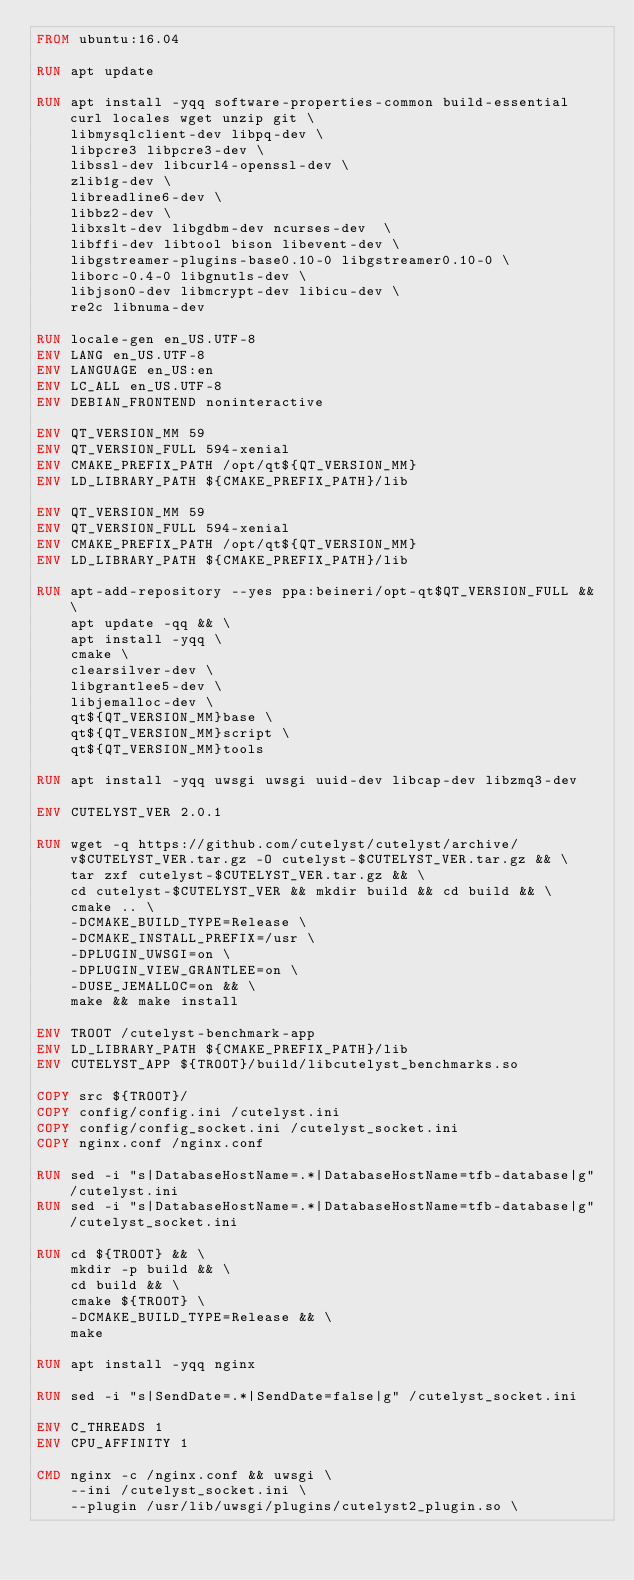<code> <loc_0><loc_0><loc_500><loc_500><_Dockerfile_>FROM ubuntu:16.04

RUN apt update

RUN apt install -yqq software-properties-common build-essential curl locales wget unzip git \
    libmysqlclient-dev libpq-dev \
    libpcre3 libpcre3-dev \
    libssl-dev libcurl4-openssl-dev \
    zlib1g-dev \
    libreadline6-dev \
    libbz2-dev \
    libxslt-dev libgdbm-dev ncurses-dev  \
    libffi-dev libtool bison libevent-dev \
    libgstreamer-plugins-base0.10-0 libgstreamer0.10-0 \
    liborc-0.4-0 libgnutls-dev \
    libjson0-dev libmcrypt-dev libicu-dev \
    re2c libnuma-dev

RUN locale-gen en_US.UTF-8
ENV LANG en_US.UTF-8
ENV LANGUAGE en_US:en
ENV LC_ALL en_US.UTF-8
ENV DEBIAN_FRONTEND noninteractive

ENV QT_VERSION_MM 59
ENV QT_VERSION_FULL 594-xenial
ENV CMAKE_PREFIX_PATH /opt/qt${QT_VERSION_MM}
ENV LD_LIBRARY_PATH ${CMAKE_PREFIX_PATH}/lib

ENV QT_VERSION_MM 59
ENV QT_VERSION_FULL 594-xenial
ENV CMAKE_PREFIX_PATH /opt/qt${QT_VERSION_MM}
ENV LD_LIBRARY_PATH ${CMAKE_PREFIX_PATH}/lib

RUN apt-add-repository --yes ppa:beineri/opt-qt$QT_VERSION_FULL && \
    apt update -qq && \
    apt install -yqq \
    cmake \
    clearsilver-dev \
    libgrantlee5-dev \
    libjemalloc-dev \
    qt${QT_VERSION_MM}base \
    qt${QT_VERSION_MM}script \
    qt${QT_VERSION_MM}tools

RUN apt install -yqq uwsgi uwsgi uuid-dev libcap-dev libzmq3-dev

ENV CUTELYST_VER 2.0.1

RUN wget -q https://github.com/cutelyst/cutelyst/archive/v$CUTELYST_VER.tar.gz -O cutelyst-$CUTELYST_VER.tar.gz && \
    tar zxf cutelyst-$CUTELYST_VER.tar.gz && \
    cd cutelyst-$CUTELYST_VER && mkdir build && cd build && \
    cmake .. \
    -DCMAKE_BUILD_TYPE=Release \
    -DCMAKE_INSTALL_PREFIX=/usr \
    -DPLUGIN_UWSGI=on \
    -DPLUGIN_VIEW_GRANTLEE=on \
    -DUSE_JEMALLOC=on && \
    make && make install

ENV TROOT /cutelyst-benchmark-app
ENV LD_LIBRARY_PATH ${CMAKE_PREFIX_PATH}/lib
ENV CUTELYST_APP ${TROOT}/build/libcutelyst_benchmarks.so

COPY src ${TROOT}/
COPY config/config.ini /cutelyst.ini
COPY config/config_socket.ini /cutelyst_socket.ini
COPY nginx.conf /nginx.conf

RUN sed -i "s|DatabaseHostName=.*|DatabaseHostName=tfb-database|g" /cutelyst.ini
RUN sed -i "s|DatabaseHostName=.*|DatabaseHostName=tfb-database|g" /cutelyst_socket.ini

RUN cd ${TROOT} && \
    mkdir -p build && \
    cd build && \
    cmake ${TROOT} \
    -DCMAKE_BUILD_TYPE=Release && \
    make

RUN apt install -yqq nginx

RUN sed -i "s|SendDate=.*|SendDate=false|g" /cutelyst_socket.ini

ENV C_THREADS 1
ENV CPU_AFFINITY 1

CMD nginx -c /nginx.conf && uwsgi \
    --ini /cutelyst_socket.ini \
    --plugin /usr/lib/uwsgi/plugins/cutelyst2_plugin.so \</code> 